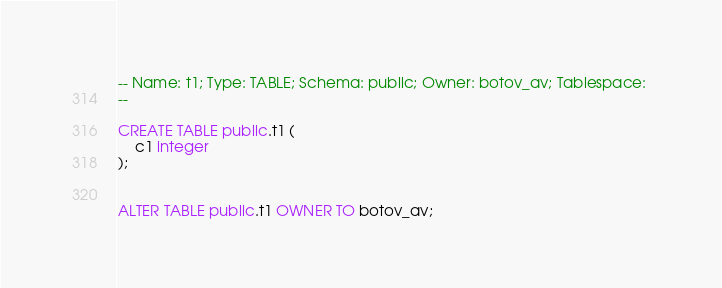<code> <loc_0><loc_0><loc_500><loc_500><_SQL_>-- Name: t1; Type: TABLE; Schema: public; Owner: botov_av; Tablespace: 
--

CREATE TABLE public.t1 (
    c1 integer
);


ALTER TABLE public.t1 OWNER TO botov_av;

</code> 